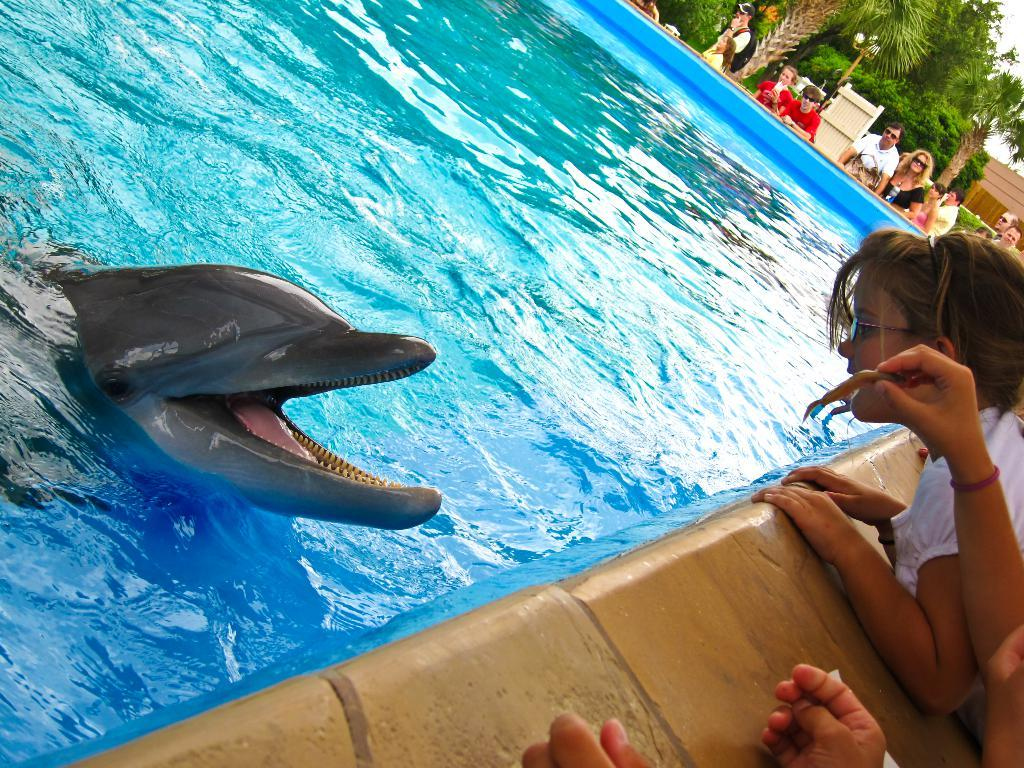What animal can be seen in the pool in the image? There is a dolphin in the pool in the image. What else is visible around the pool? There are people around the pool in the image. What can be seen in the background of the image? There are trees visible in the image. What type of lighting is present in the image? There are lights in the image. What type of structure is visible in the image? There is a building in the image. What type of scarf is the carpenter wearing while handling the poison in the image? There is no carpenter, scarf, or poison present in the image. 